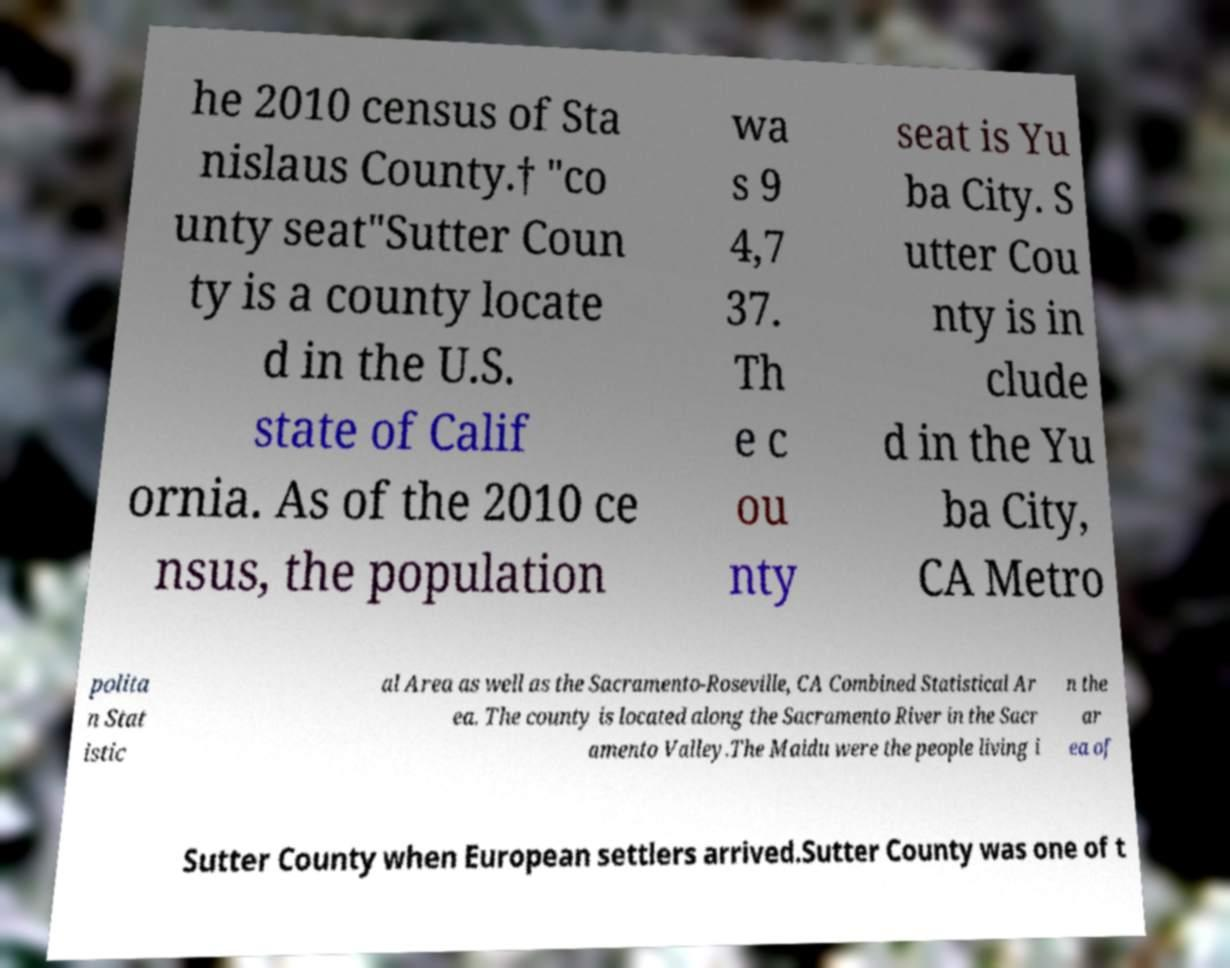What messages or text are displayed in this image? I need them in a readable, typed format. he 2010 census of Sta nislaus County.† "co unty seat"Sutter Coun ty is a county locate d in the U.S. state of Calif ornia. As of the 2010 ce nsus, the population wa s 9 4,7 37. Th e c ou nty seat is Yu ba City. S utter Cou nty is in clude d in the Yu ba City, CA Metro polita n Stat istic al Area as well as the Sacramento-Roseville, CA Combined Statistical Ar ea. The county is located along the Sacramento River in the Sacr amento Valley.The Maidu were the people living i n the ar ea of Sutter County when European settlers arrived.Sutter County was one of t 